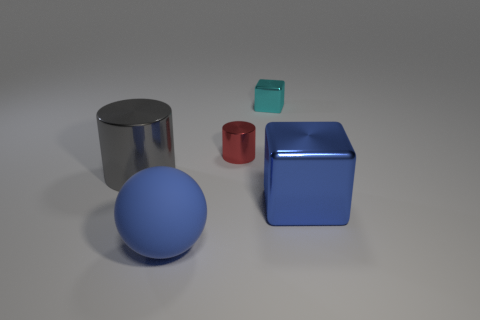What could you infer about the environment in which these objects are placed? The environment appears to be a simple, unadorned space that might be used for a photoshoot or rendering test. The lack of additional context, and a neutral background, emphasizes the forms and materials of the objects, which suggests the image could be designed for examining object qualities or for an artistic purpose. 